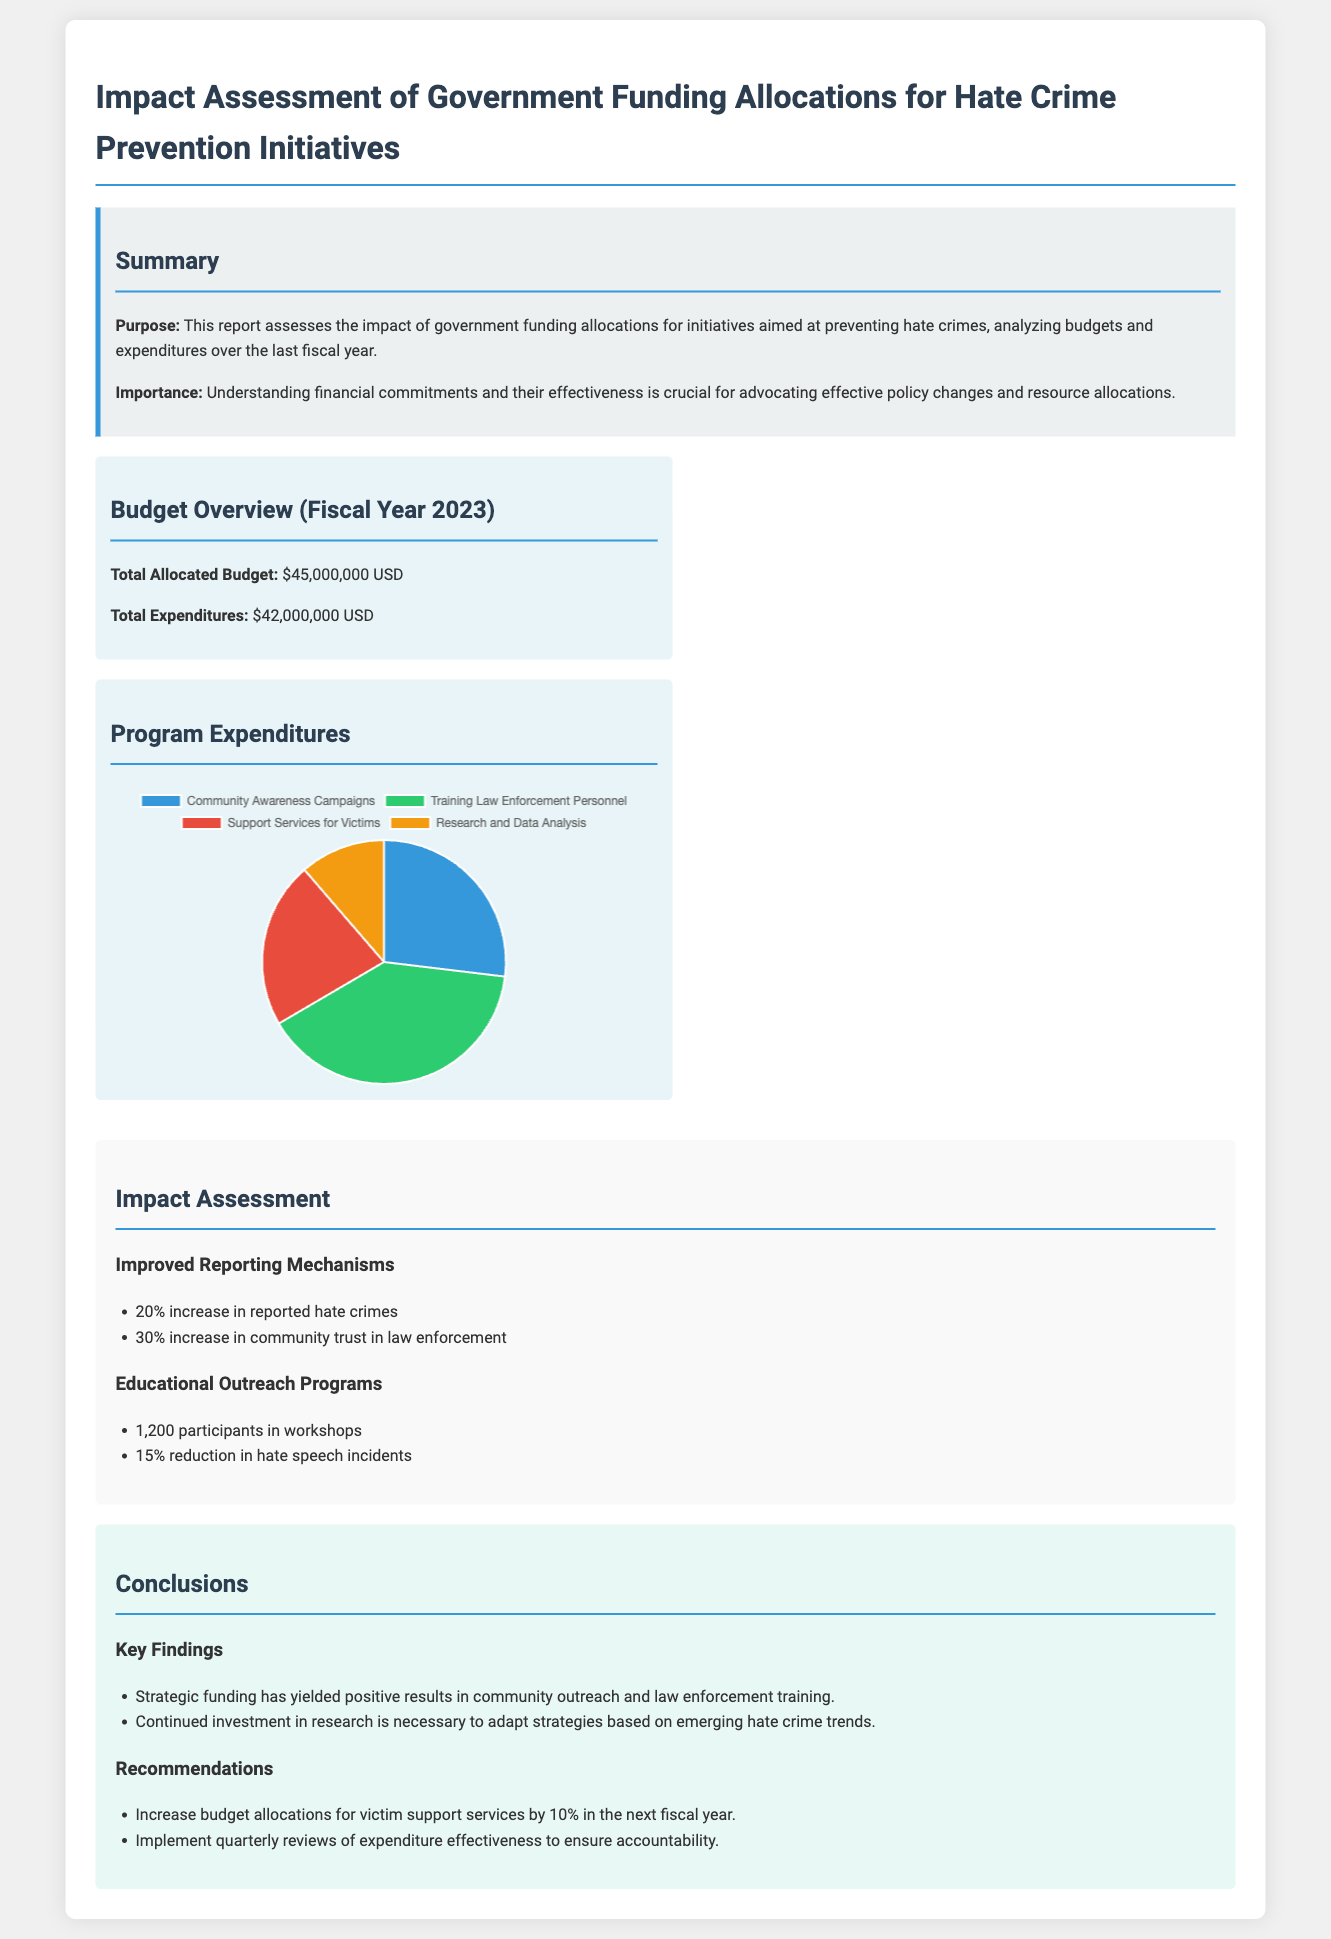what was the total allocated budget? The total allocated budget in the document is explicitly stated as $45,000,000 USD.
Answer: $45,000,000 USD how much was spent in total expenditures? The total expenditures are detailed in the document as amounting to $42,000,000 USD.
Answer: $42,000,000 USD what percentage increase was reported in community trust in law enforcement? The document mentions a 30% increase in community trust in law enforcement as a result of initiatives.
Answer: 30% how many participants were involved in educational outreach programs? The document specifies that there were 1,200 participants in the workshops related to educational outreach programs.
Answer: 1,200 what is one of the key findings from the conclusions section? The key findings highlighted in the conclusions indicate the effectiveness of strategic funding in community outreach and law enforcement training.
Answer: Strategic funding has yielded positive results what is the recommended percentage increase for victim support services budget in the next fiscal year? The document recommends a 10% increase in budget allocations for victim support services for the upcoming fiscal year.
Answer: 10% how many categories are outlined in the program expenditures chart? The document contains four categories detailed in the expenditures chart, which are Community Awareness Campaigns, Training Law Enforcement Personnel, Support Services for Victims, and Research and Data Analysis.
Answer: Four what is the purpose of this report? The purpose of the report is to assess the impact of government funding allocations for initiatives aimed at preventing hate crimes.
Answer: Assess the impact of government funding allocations 